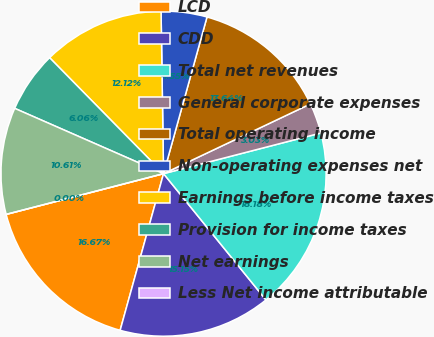Convert chart to OTSL. <chart><loc_0><loc_0><loc_500><loc_500><pie_chart><fcel>LCD<fcel>CDD<fcel>Total net revenues<fcel>General corporate expenses<fcel>Total operating income<fcel>Non-operating expenses net<fcel>Earnings before income taxes<fcel>Provision for income taxes<fcel>Net earnings<fcel>Less Net income attributable<nl><fcel>16.67%<fcel>15.15%<fcel>18.18%<fcel>3.03%<fcel>13.64%<fcel>4.55%<fcel>12.12%<fcel>6.06%<fcel>10.61%<fcel>0.0%<nl></chart> 